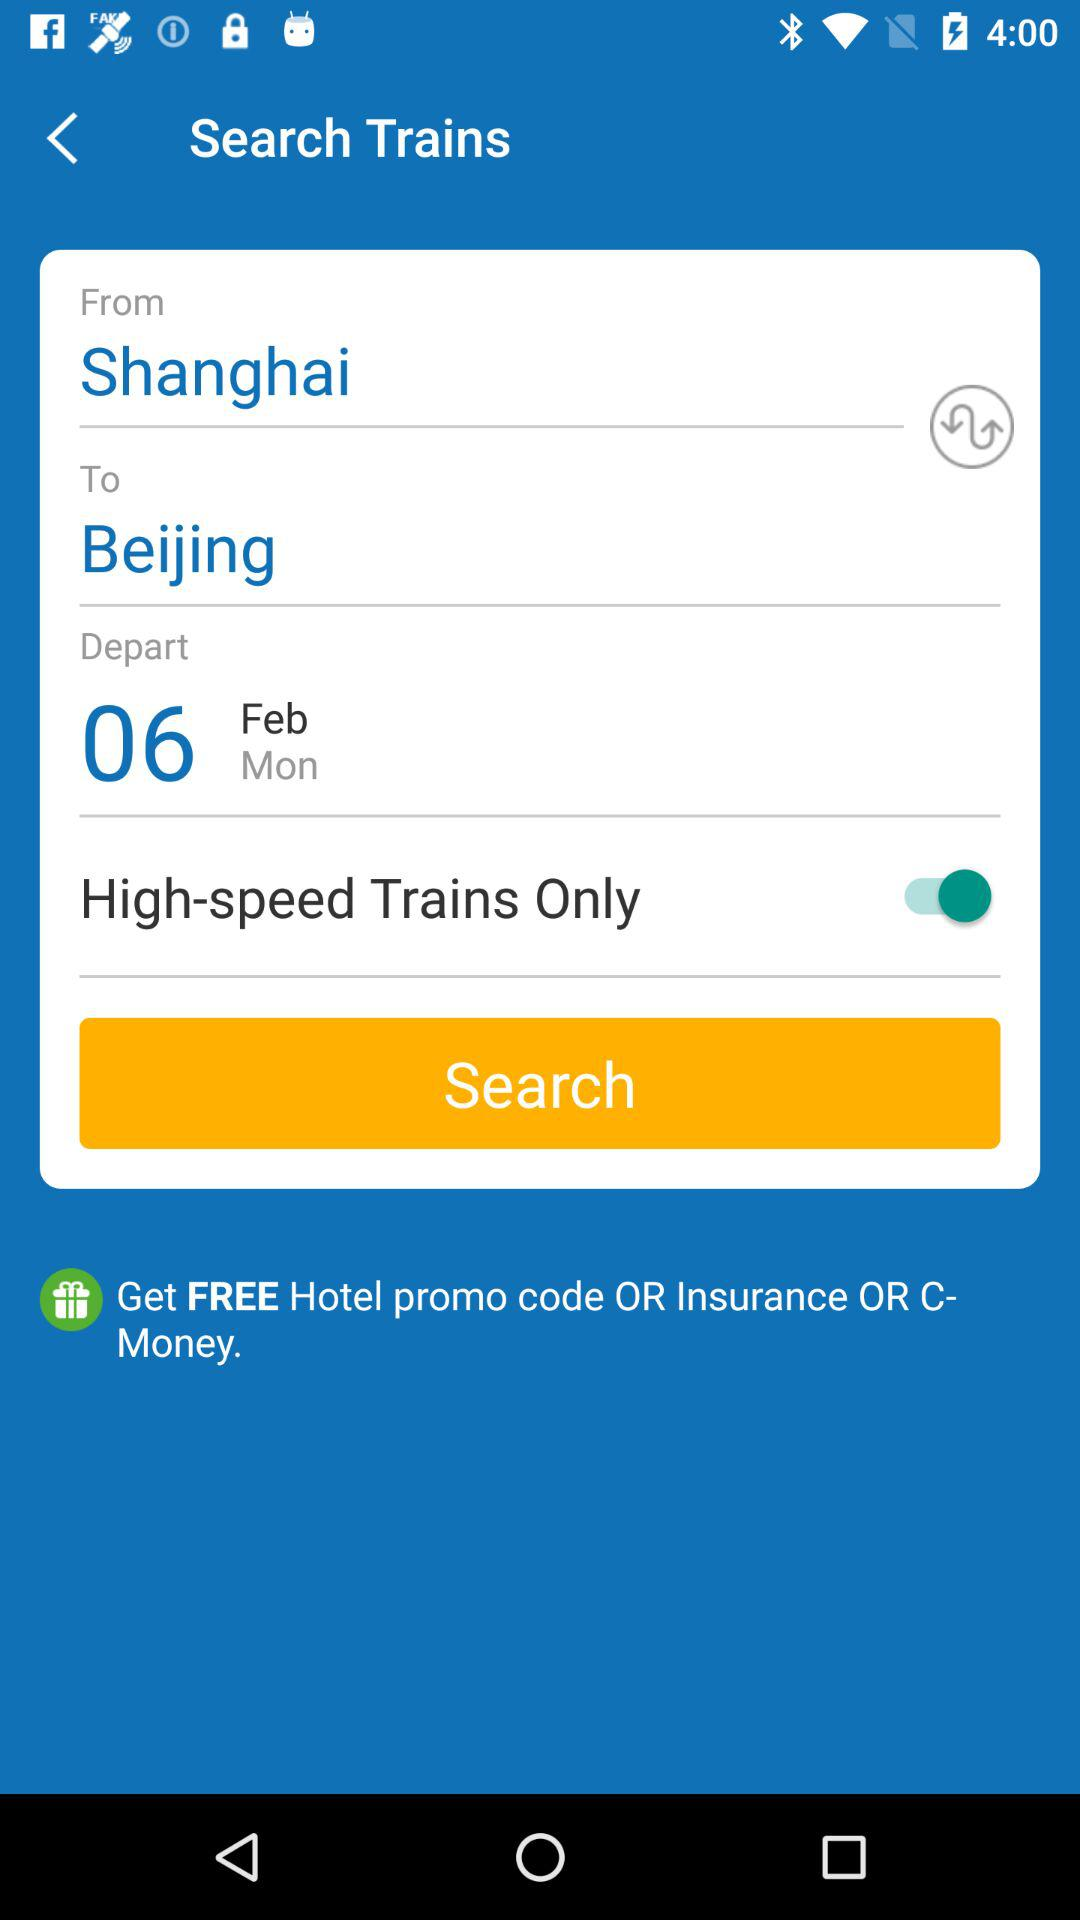What is the day on February 06? The day is Monday. 